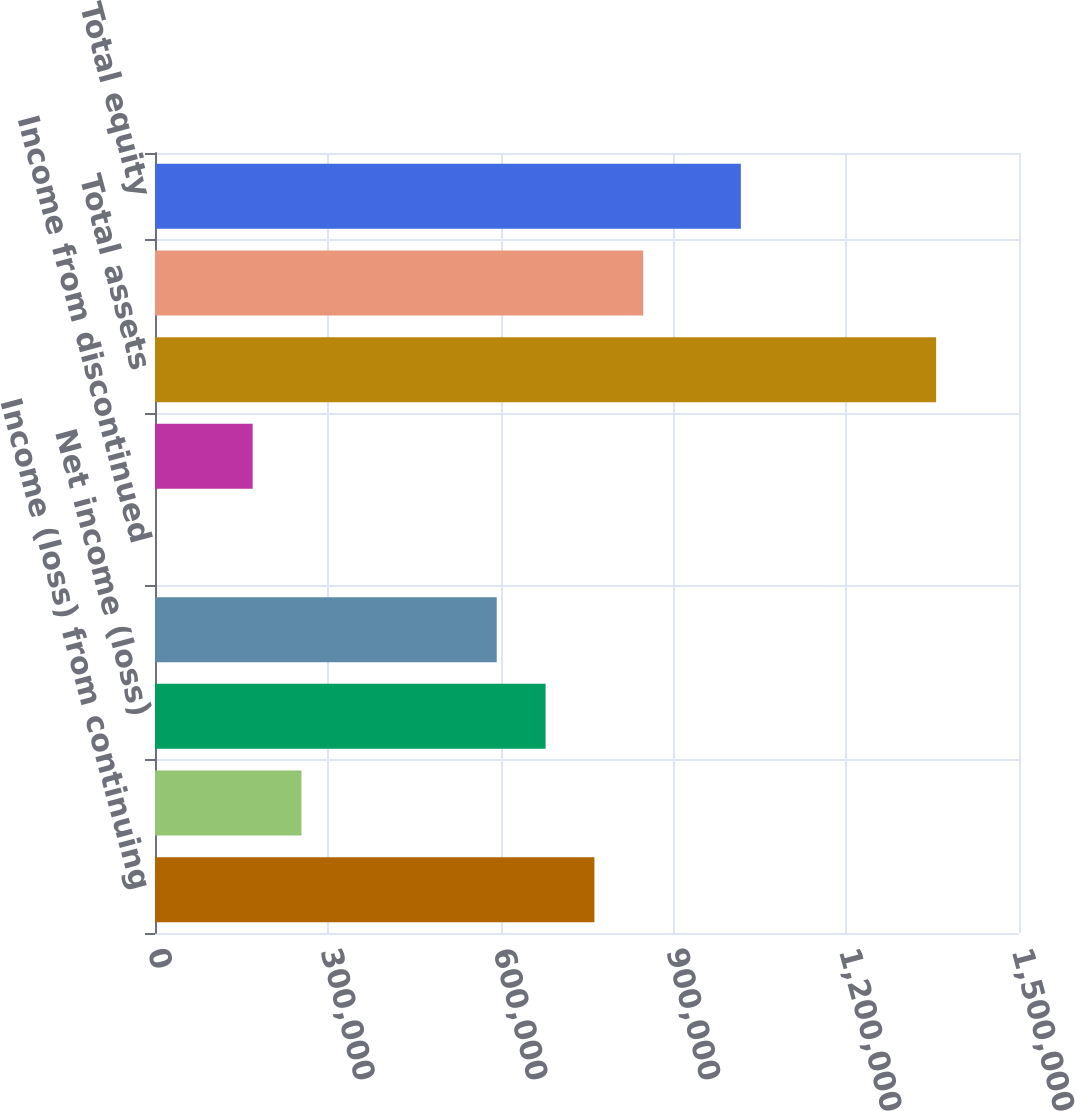Convert chart. <chart><loc_0><loc_0><loc_500><loc_500><bar_chart><fcel>Income (loss) from continuing<fcel>Income (loss) from<fcel>Net income (loss)<fcel>Net income (loss) attributable<fcel>Income from discontinued<fcel>Income (loss) attributable to<fcel>Total assets<fcel>Total AIG shareholders' equity<fcel>Total equity<nl><fcel>762828<fcel>254283<fcel>678070<fcel>593313<fcel>11.22<fcel>169526<fcel>1.35613e+06<fcel>847585<fcel>1.0171e+06<nl></chart> 